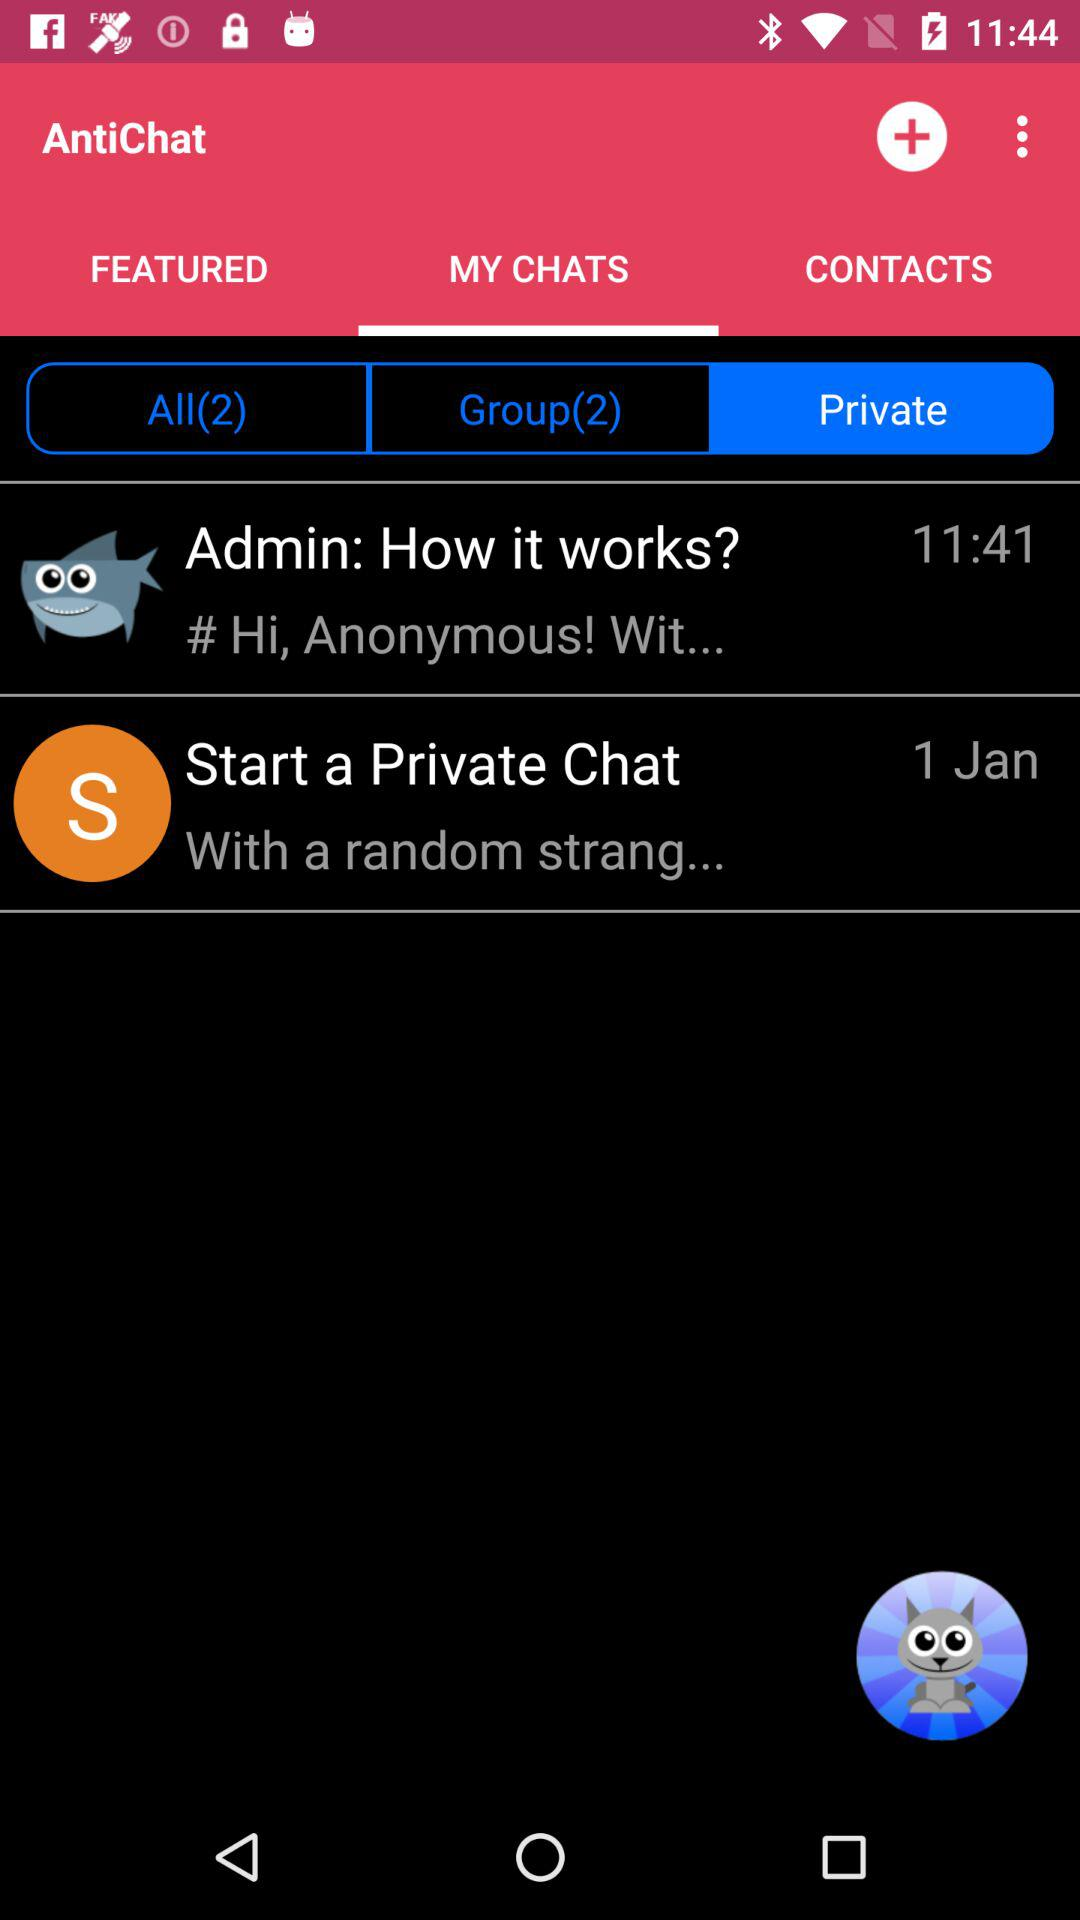What is the mentioned date for "Start a Private Chat"? The mentioned date for "Start a Private Chat" is January 1. 